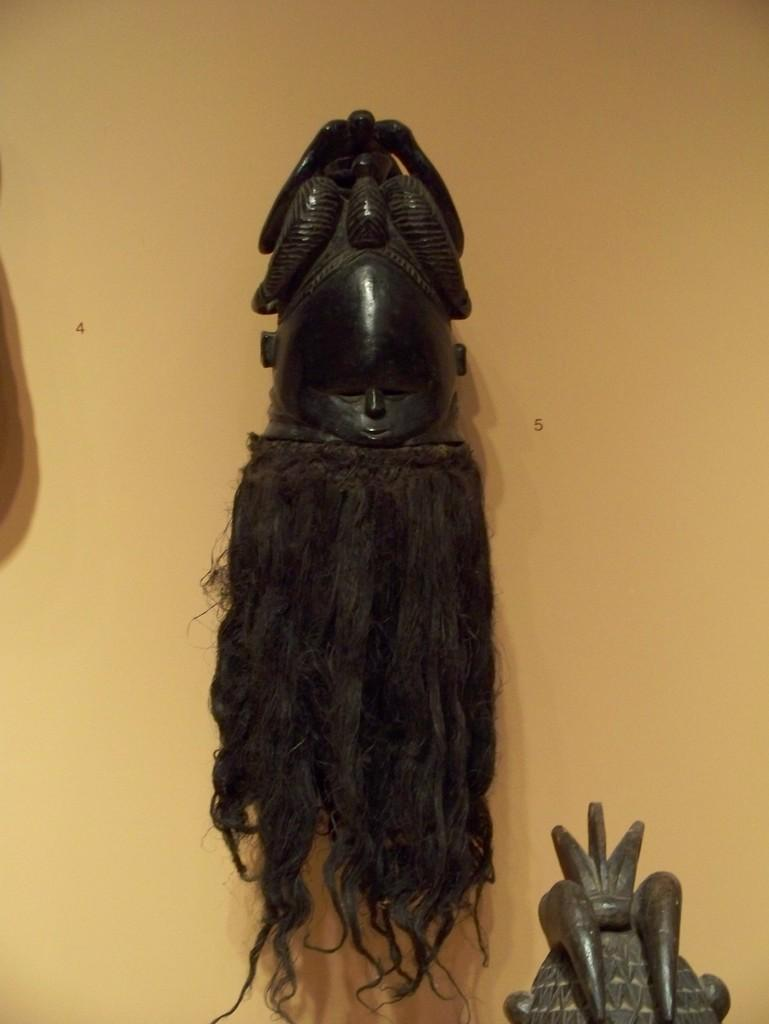What color is the wall that is visible in the image? There is a yellow color wall in the image. What is attached to the wall in the image? There are objects attached to the wall. What else can be seen in the image besides the wall and attached objects? There are other objects visible in the image. What type of beef is being served on the airplane in the image? There is no airplane or beef present in the image; it only features a yellow color wall with objects attached to it and other visible objects. 